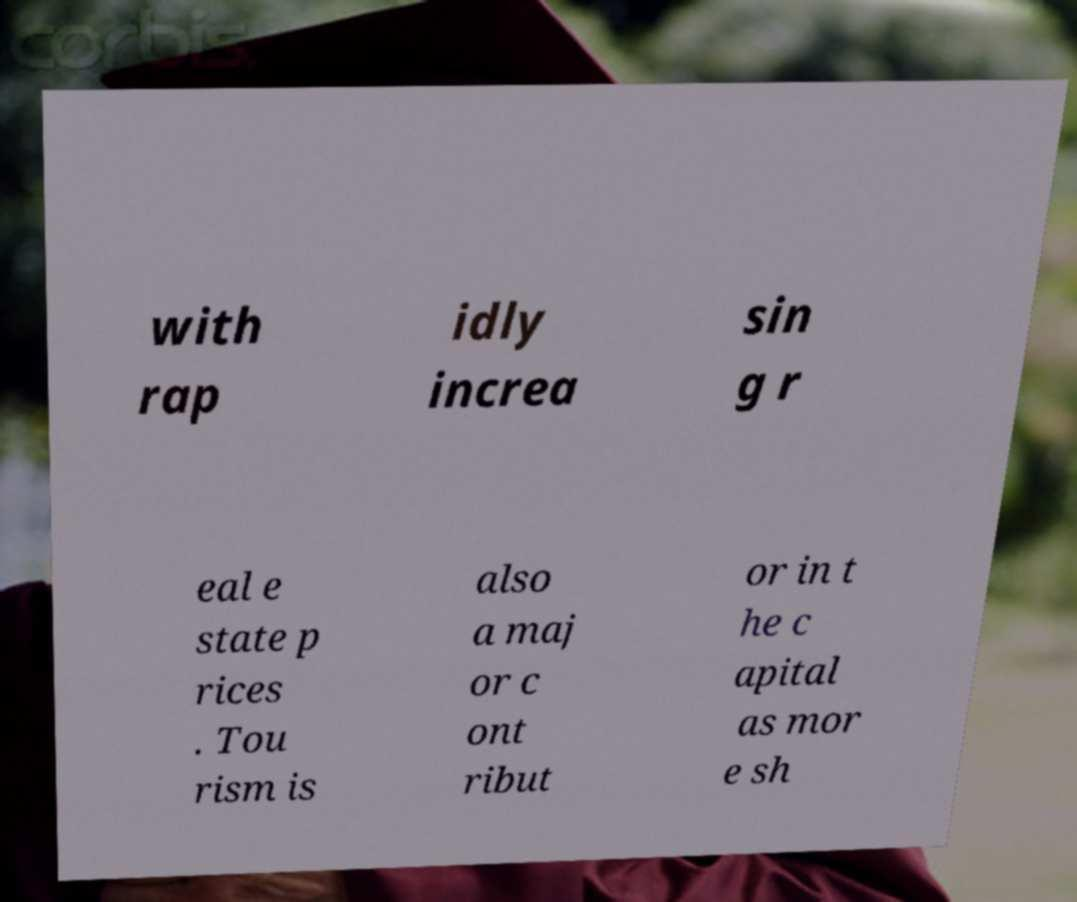Please identify and transcribe the text found in this image. with rap idly increa sin g r eal e state p rices . Tou rism is also a maj or c ont ribut or in t he c apital as mor e sh 